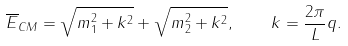<formula> <loc_0><loc_0><loc_500><loc_500>\overline { E } _ { C M } = \sqrt { m _ { 1 } ^ { 2 } + k ^ { 2 } } + \sqrt { m _ { 2 } ^ { 2 } + k ^ { 2 } } , \quad k = \frac { 2 \pi } { L } q .</formula> 